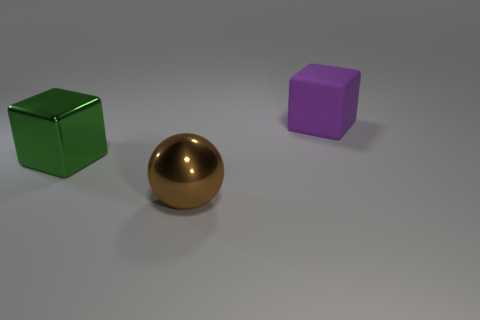There is a thing behind the large green thing; what material is it?
Your answer should be compact. Rubber. How big is the object in front of the thing that is left of the brown shiny object that is to the right of the big green metal cube?
Your answer should be very brief. Large. Is the size of the rubber thing the same as the cube to the left of the matte block?
Your answer should be very brief. Yes. The large cube that is in front of the big matte block is what color?
Make the answer very short. Green. The large metal object that is behind the big brown ball has what shape?
Ensure brevity in your answer.  Cube. What number of green objects are matte objects or big things?
Your response must be concise. 1. Are the purple cube and the big green thing made of the same material?
Offer a very short reply. No. How many rubber cubes are on the right side of the purple rubber object?
Offer a very short reply. 0. There is a thing that is both on the right side of the green cube and in front of the purple thing; what material is it?
Your answer should be compact. Metal. What number of cylinders are metallic objects or big purple things?
Provide a short and direct response. 0. 